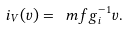<formula> <loc_0><loc_0><loc_500><loc_500>i _ { V } ( v ) = { \ m f g } _ { i } ^ { - 1 } v .</formula> 